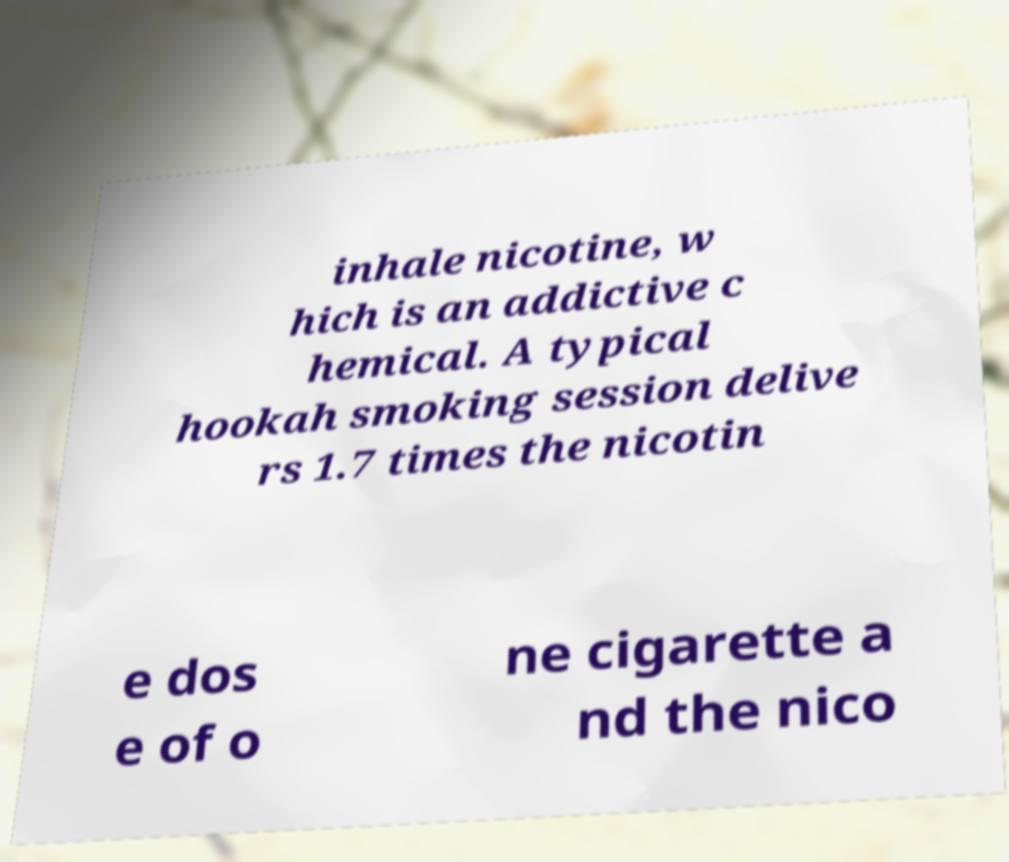Please read and relay the text visible in this image. What does it say? inhale nicotine, w hich is an addictive c hemical. A typical hookah smoking session delive rs 1.7 times the nicotin e dos e of o ne cigarette a nd the nico 